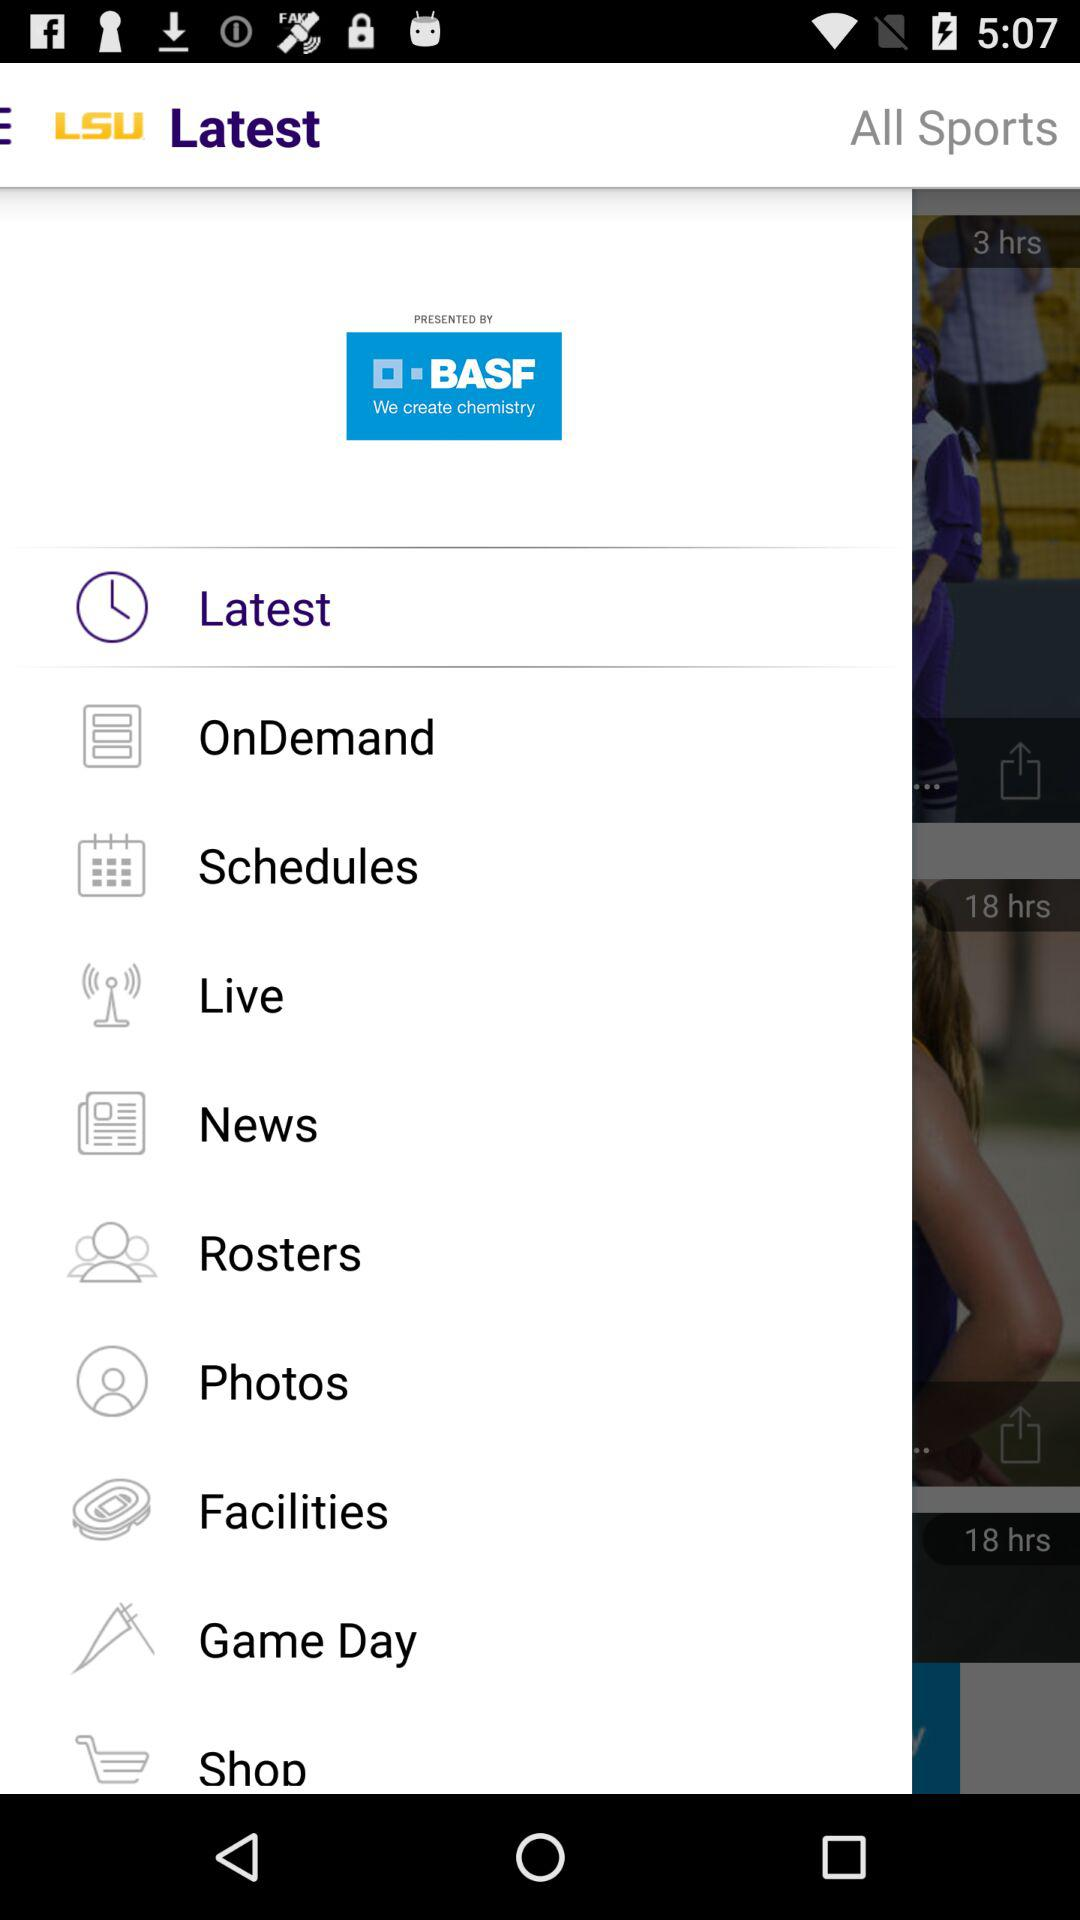How many hours ago was the latest video uploaded?
Answer the question using a single word or phrase. 3 